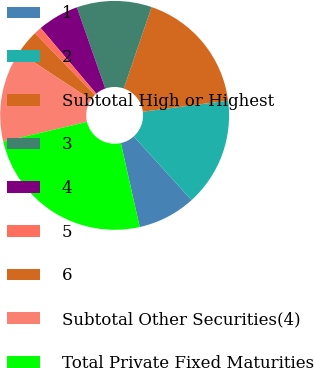<chart> <loc_0><loc_0><loc_500><loc_500><pie_chart><fcel>1<fcel>2<fcel>Subtotal High or Highest<fcel>3<fcel>4<fcel>5<fcel>6<fcel>Subtotal Other Securities(4)<fcel>Total Private Fixed Maturities<nl><fcel>8.21%<fcel>15.33%<fcel>17.71%<fcel>10.58%<fcel>5.83%<fcel>1.08%<fcel>3.46%<fcel>12.96%<fcel>24.83%<nl></chart> 